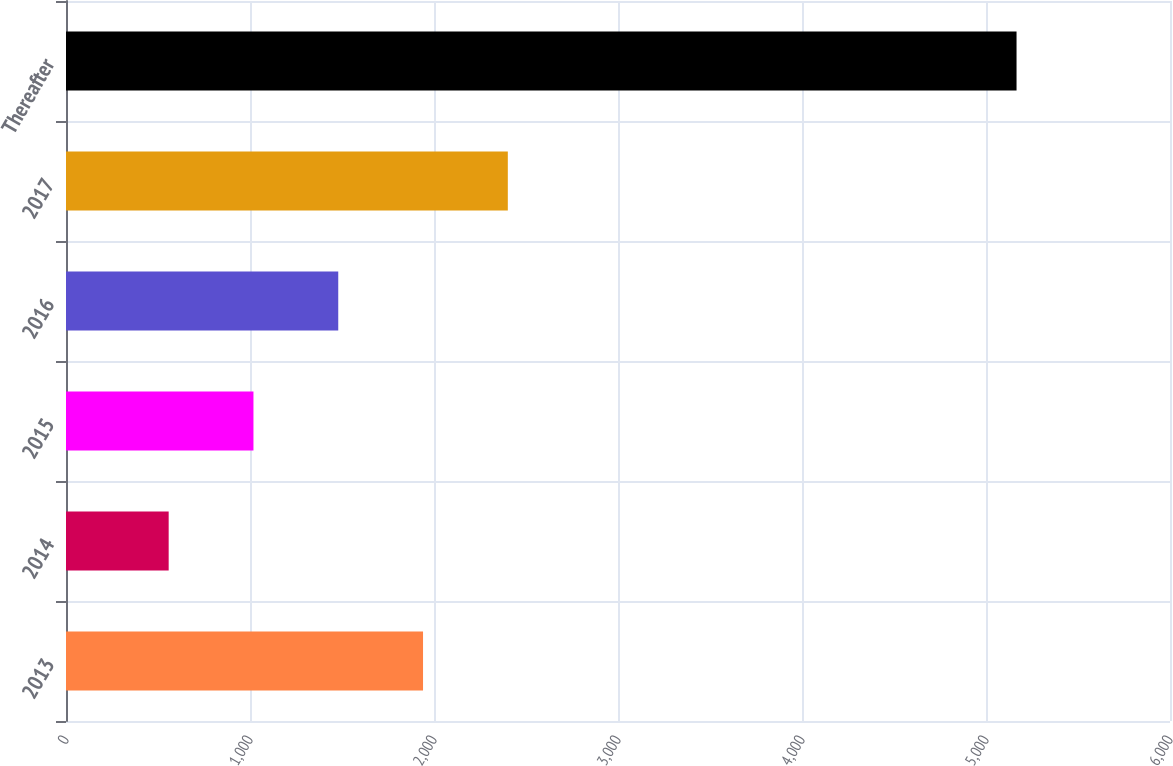Convert chart. <chart><loc_0><loc_0><loc_500><loc_500><bar_chart><fcel>2013<fcel>2014<fcel>2015<fcel>2016<fcel>2017<fcel>Thereafter<nl><fcel>1940.4<fcel>558<fcel>1018.8<fcel>1479.6<fcel>2401.2<fcel>5166<nl></chart> 